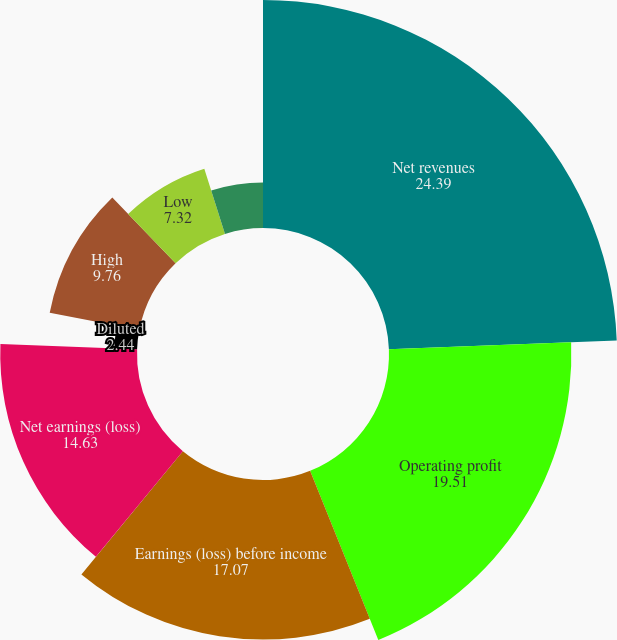Convert chart to OTSL. <chart><loc_0><loc_0><loc_500><loc_500><pie_chart><fcel>Net revenues<fcel>Operating profit<fcel>Earnings (loss) before income<fcel>Net earnings (loss)<fcel>Basic<fcel>Diluted<fcel>High<fcel>Low<fcel>Cash dividends declared<nl><fcel>24.39%<fcel>19.51%<fcel>17.07%<fcel>14.63%<fcel>0.0%<fcel>2.44%<fcel>9.76%<fcel>7.32%<fcel>4.88%<nl></chart> 